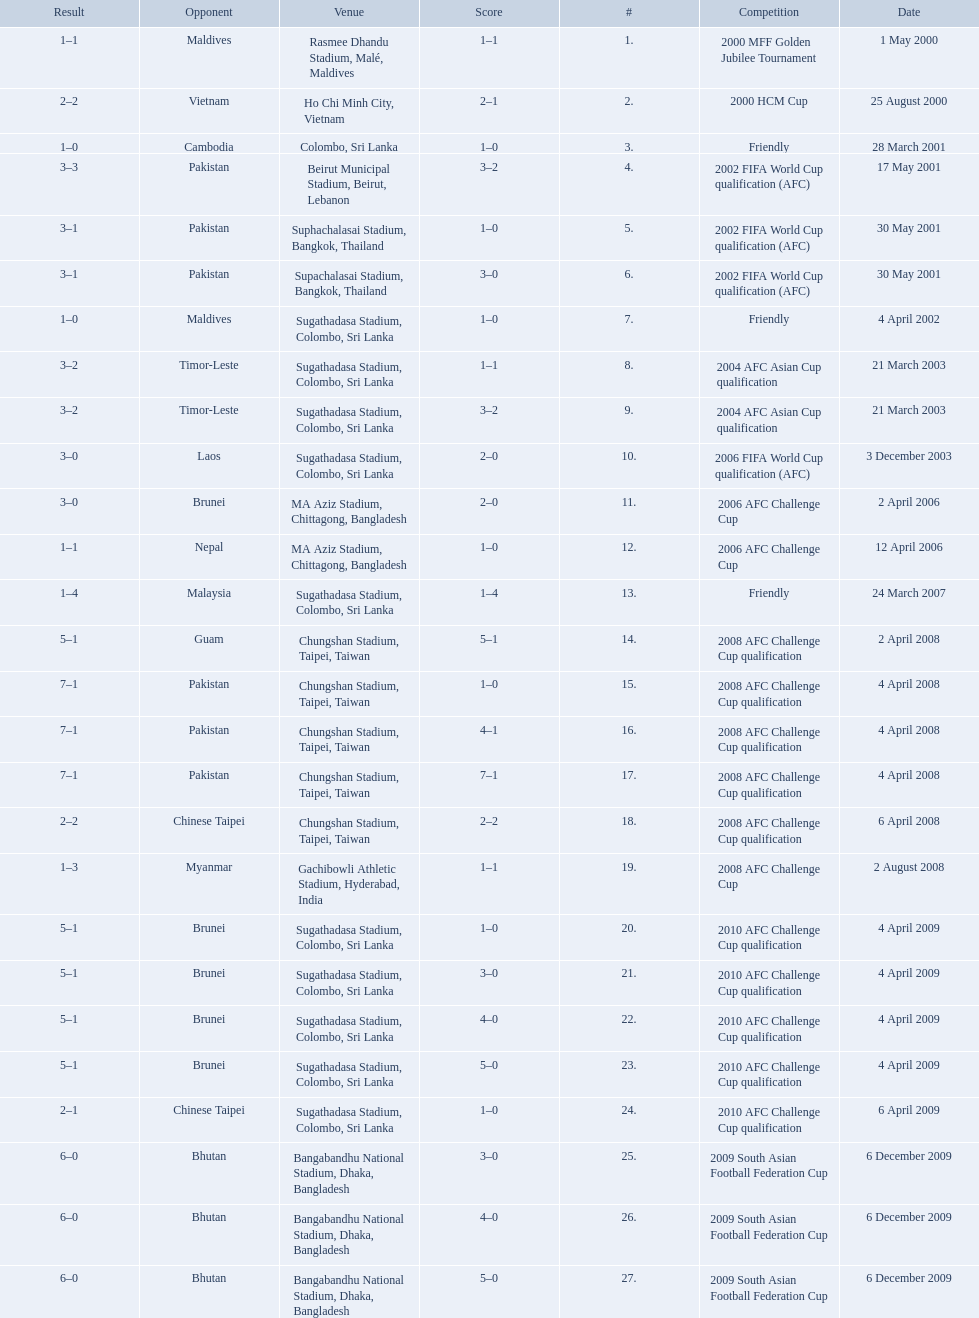How many venues are in the table? 27. Which one is the top listed? Rasmee Dhandu Stadium, Malé, Maldives. What venues are listed? Rasmee Dhandu Stadium, Malé, Maldives, Ho Chi Minh City, Vietnam, Colombo, Sri Lanka, Beirut Municipal Stadium, Beirut, Lebanon, Suphachalasai Stadium, Bangkok, Thailand, MA Aziz Stadium, Chittagong, Bangladesh, Sugathadasa Stadium, Colombo, Sri Lanka, Chungshan Stadium, Taipei, Taiwan, Gachibowli Athletic Stadium, Hyderabad, India, Sugathadasa Stadium, Colombo, Sri Lanka, Bangabandhu National Stadium, Dhaka, Bangladesh. Which is top listed? Rasmee Dhandu Stadium, Malé, Maldives. 